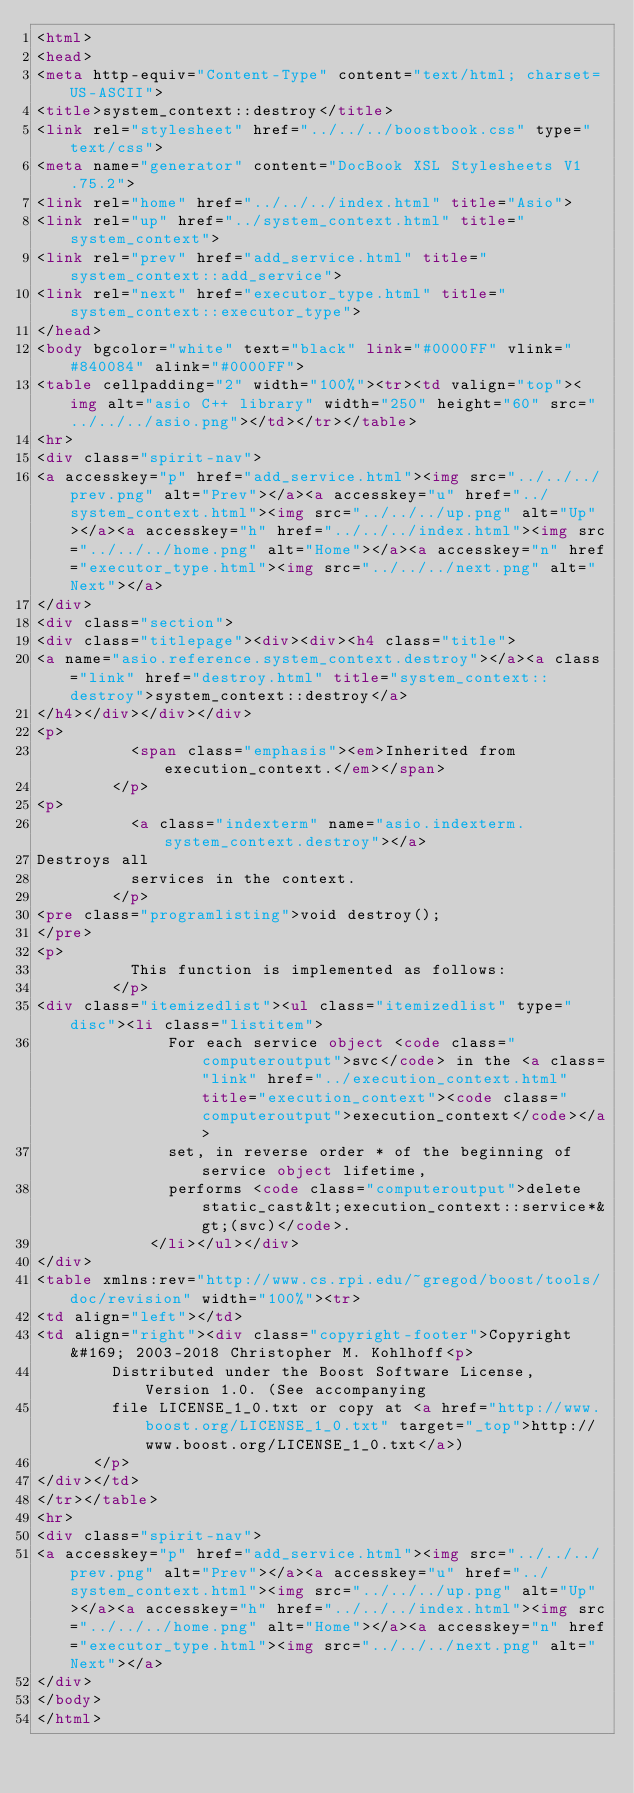Convert code to text. <code><loc_0><loc_0><loc_500><loc_500><_HTML_><html>
<head>
<meta http-equiv="Content-Type" content="text/html; charset=US-ASCII">
<title>system_context::destroy</title>
<link rel="stylesheet" href="../../../boostbook.css" type="text/css">
<meta name="generator" content="DocBook XSL Stylesheets V1.75.2">
<link rel="home" href="../../../index.html" title="Asio">
<link rel="up" href="../system_context.html" title="system_context">
<link rel="prev" href="add_service.html" title="system_context::add_service">
<link rel="next" href="executor_type.html" title="system_context::executor_type">
</head>
<body bgcolor="white" text="black" link="#0000FF" vlink="#840084" alink="#0000FF">
<table cellpadding="2" width="100%"><tr><td valign="top"><img alt="asio C++ library" width="250" height="60" src="../../../asio.png"></td></tr></table>
<hr>
<div class="spirit-nav">
<a accesskey="p" href="add_service.html"><img src="../../../prev.png" alt="Prev"></a><a accesskey="u" href="../system_context.html"><img src="../../../up.png" alt="Up"></a><a accesskey="h" href="../../../index.html"><img src="../../../home.png" alt="Home"></a><a accesskey="n" href="executor_type.html"><img src="../../../next.png" alt="Next"></a>
</div>
<div class="section">
<div class="titlepage"><div><div><h4 class="title">
<a name="asio.reference.system_context.destroy"></a><a class="link" href="destroy.html" title="system_context::destroy">system_context::destroy</a>
</h4></div></div></div>
<p>
          <span class="emphasis"><em>Inherited from execution_context.</em></span>
        </p>
<p>
          <a class="indexterm" name="asio.indexterm.system_context.destroy"></a> 
Destroys all
          services in the context.
        </p>
<pre class="programlisting">void destroy();
</pre>
<p>
          This function is implemented as follows:
        </p>
<div class="itemizedlist"><ul class="itemizedlist" type="disc"><li class="listitem">
              For each service object <code class="computeroutput">svc</code> in the <a class="link" href="../execution_context.html" title="execution_context"><code class="computeroutput">execution_context</code></a>
              set, in reverse order * of the beginning of service object lifetime,
              performs <code class="computeroutput">delete static_cast&lt;execution_context::service*&gt;(svc)</code>.
            </li></ul></div>
</div>
<table xmlns:rev="http://www.cs.rpi.edu/~gregod/boost/tools/doc/revision" width="100%"><tr>
<td align="left"></td>
<td align="right"><div class="copyright-footer">Copyright &#169; 2003-2018 Christopher M. Kohlhoff<p>
        Distributed under the Boost Software License, Version 1.0. (See accompanying
        file LICENSE_1_0.txt or copy at <a href="http://www.boost.org/LICENSE_1_0.txt" target="_top">http://www.boost.org/LICENSE_1_0.txt</a>)
      </p>
</div></td>
</tr></table>
<hr>
<div class="spirit-nav">
<a accesskey="p" href="add_service.html"><img src="../../../prev.png" alt="Prev"></a><a accesskey="u" href="../system_context.html"><img src="../../../up.png" alt="Up"></a><a accesskey="h" href="../../../index.html"><img src="../../../home.png" alt="Home"></a><a accesskey="n" href="executor_type.html"><img src="../../../next.png" alt="Next"></a>
</div>
</body>
</html>
</code> 